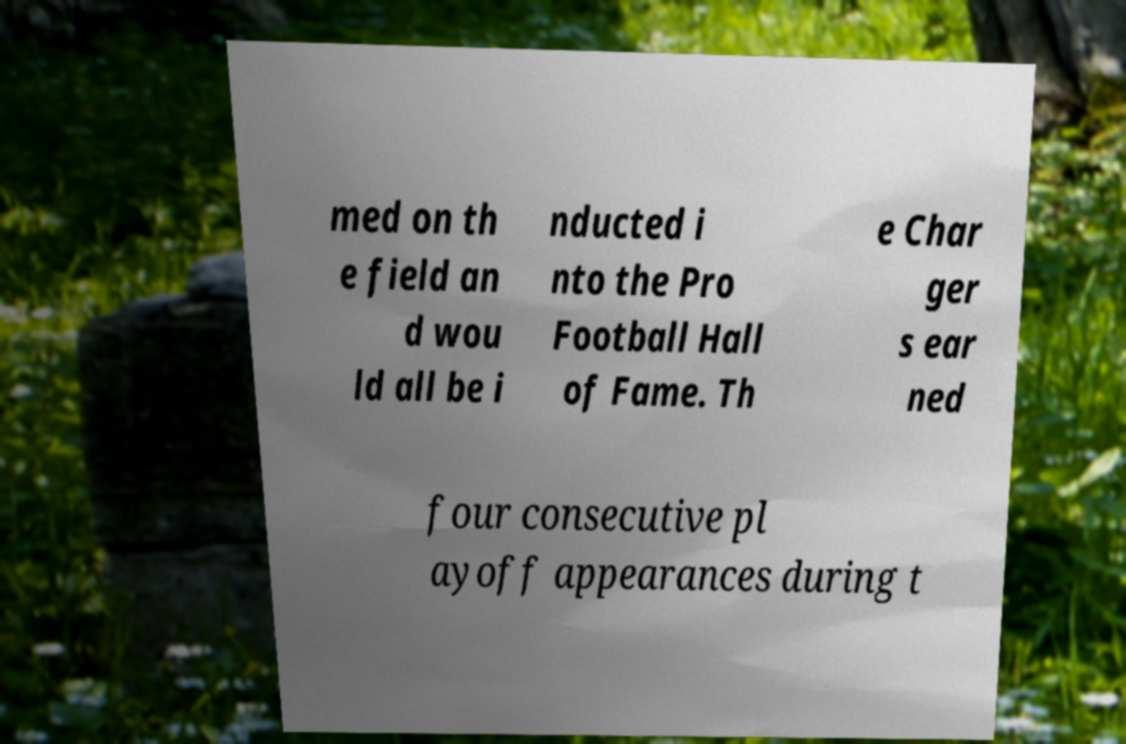What messages or text are displayed in this image? I need them in a readable, typed format. med on th e field an d wou ld all be i nducted i nto the Pro Football Hall of Fame. Th e Char ger s ear ned four consecutive pl ayoff appearances during t 